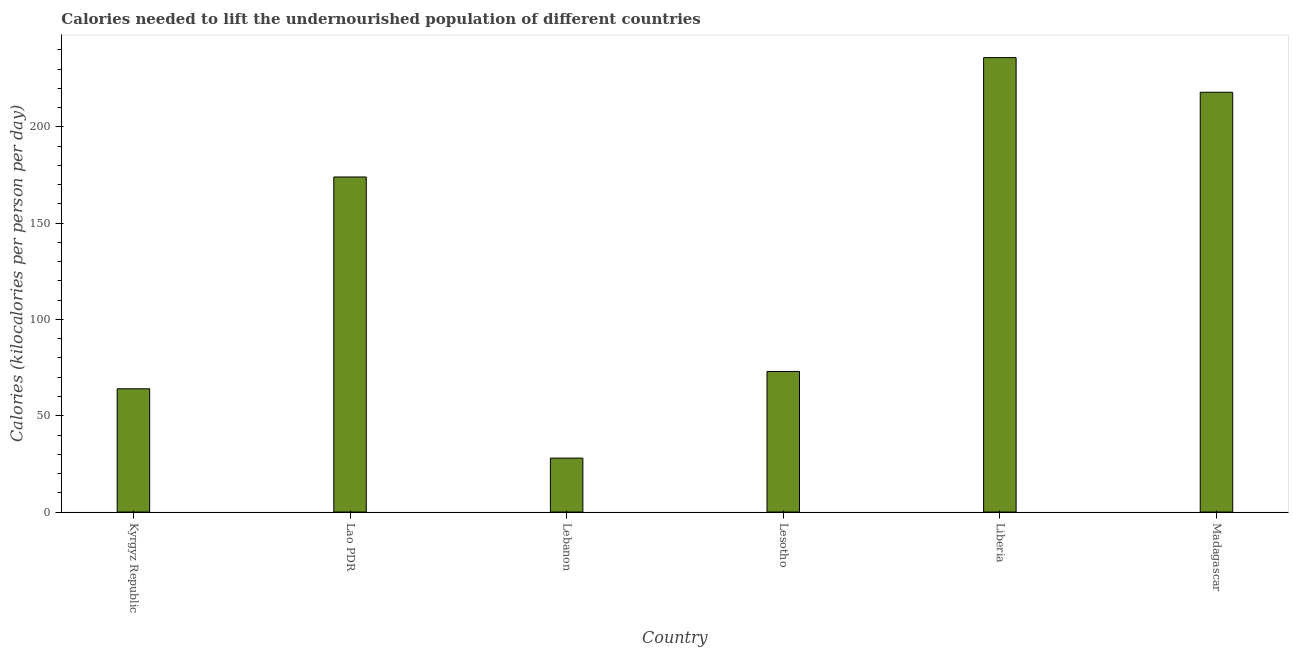What is the title of the graph?
Provide a short and direct response. Calories needed to lift the undernourished population of different countries. What is the label or title of the X-axis?
Your answer should be very brief. Country. What is the label or title of the Y-axis?
Your answer should be very brief. Calories (kilocalories per person per day). What is the depth of food deficit in Lao PDR?
Keep it short and to the point. 174. Across all countries, what is the maximum depth of food deficit?
Give a very brief answer. 236. In which country was the depth of food deficit maximum?
Your response must be concise. Liberia. In which country was the depth of food deficit minimum?
Offer a very short reply. Lebanon. What is the sum of the depth of food deficit?
Provide a short and direct response. 793. What is the average depth of food deficit per country?
Make the answer very short. 132.17. What is the median depth of food deficit?
Provide a short and direct response. 123.5. What is the ratio of the depth of food deficit in Kyrgyz Republic to that in Madagascar?
Offer a terse response. 0.29. Is the depth of food deficit in Kyrgyz Republic less than that in Lao PDR?
Your answer should be very brief. Yes. Is the difference between the depth of food deficit in Lesotho and Madagascar greater than the difference between any two countries?
Ensure brevity in your answer.  No. Is the sum of the depth of food deficit in Kyrgyz Republic and Liberia greater than the maximum depth of food deficit across all countries?
Provide a short and direct response. Yes. What is the difference between the highest and the lowest depth of food deficit?
Provide a short and direct response. 208. In how many countries, is the depth of food deficit greater than the average depth of food deficit taken over all countries?
Offer a terse response. 3. Are all the bars in the graph horizontal?
Ensure brevity in your answer.  No. What is the difference between two consecutive major ticks on the Y-axis?
Offer a terse response. 50. What is the Calories (kilocalories per person per day) of Kyrgyz Republic?
Offer a very short reply. 64. What is the Calories (kilocalories per person per day) in Lao PDR?
Ensure brevity in your answer.  174. What is the Calories (kilocalories per person per day) of Lebanon?
Make the answer very short. 28. What is the Calories (kilocalories per person per day) of Lesotho?
Make the answer very short. 73. What is the Calories (kilocalories per person per day) of Liberia?
Keep it short and to the point. 236. What is the Calories (kilocalories per person per day) in Madagascar?
Your answer should be very brief. 218. What is the difference between the Calories (kilocalories per person per day) in Kyrgyz Republic and Lao PDR?
Your answer should be very brief. -110. What is the difference between the Calories (kilocalories per person per day) in Kyrgyz Republic and Lesotho?
Give a very brief answer. -9. What is the difference between the Calories (kilocalories per person per day) in Kyrgyz Republic and Liberia?
Your answer should be very brief. -172. What is the difference between the Calories (kilocalories per person per day) in Kyrgyz Republic and Madagascar?
Keep it short and to the point. -154. What is the difference between the Calories (kilocalories per person per day) in Lao PDR and Lebanon?
Offer a terse response. 146. What is the difference between the Calories (kilocalories per person per day) in Lao PDR and Lesotho?
Offer a terse response. 101. What is the difference between the Calories (kilocalories per person per day) in Lao PDR and Liberia?
Offer a terse response. -62. What is the difference between the Calories (kilocalories per person per day) in Lao PDR and Madagascar?
Ensure brevity in your answer.  -44. What is the difference between the Calories (kilocalories per person per day) in Lebanon and Lesotho?
Keep it short and to the point. -45. What is the difference between the Calories (kilocalories per person per day) in Lebanon and Liberia?
Keep it short and to the point. -208. What is the difference between the Calories (kilocalories per person per day) in Lebanon and Madagascar?
Your response must be concise. -190. What is the difference between the Calories (kilocalories per person per day) in Lesotho and Liberia?
Give a very brief answer. -163. What is the difference between the Calories (kilocalories per person per day) in Lesotho and Madagascar?
Keep it short and to the point. -145. What is the difference between the Calories (kilocalories per person per day) in Liberia and Madagascar?
Your answer should be very brief. 18. What is the ratio of the Calories (kilocalories per person per day) in Kyrgyz Republic to that in Lao PDR?
Your answer should be very brief. 0.37. What is the ratio of the Calories (kilocalories per person per day) in Kyrgyz Republic to that in Lebanon?
Your answer should be very brief. 2.29. What is the ratio of the Calories (kilocalories per person per day) in Kyrgyz Republic to that in Lesotho?
Your answer should be very brief. 0.88. What is the ratio of the Calories (kilocalories per person per day) in Kyrgyz Republic to that in Liberia?
Provide a succinct answer. 0.27. What is the ratio of the Calories (kilocalories per person per day) in Kyrgyz Republic to that in Madagascar?
Keep it short and to the point. 0.29. What is the ratio of the Calories (kilocalories per person per day) in Lao PDR to that in Lebanon?
Keep it short and to the point. 6.21. What is the ratio of the Calories (kilocalories per person per day) in Lao PDR to that in Lesotho?
Provide a succinct answer. 2.38. What is the ratio of the Calories (kilocalories per person per day) in Lao PDR to that in Liberia?
Offer a terse response. 0.74. What is the ratio of the Calories (kilocalories per person per day) in Lao PDR to that in Madagascar?
Ensure brevity in your answer.  0.8. What is the ratio of the Calories (kilocalories per person per day) in Lebanon to that in Lesotho?
Your answer should be compact. 0.38. What is the ratio of the Calories (kilocalories per person per day) in Lebanon to that in Liberia?
Offer a terse response. 0.12. What is the ratio of the Calories (kilocalories per person per day) in Lebanon to that in Madagascar?
Ensure brevity in your answer.  0.13. What is the ratio of the Calories (kilocalories per person per day) in Lesotho to that in Liberia?
Your response must be concise. 0.31. What is the ratio of the Calories (kilocalories per person per day) in Lesotho to that in Madagascar?
Ensure brevity in your answer.  0.34. What is the ratio of the Calories (kilocalories per person per day) in Liberia to that in Madagascar?
Your answer should be very brief. 1.08. 